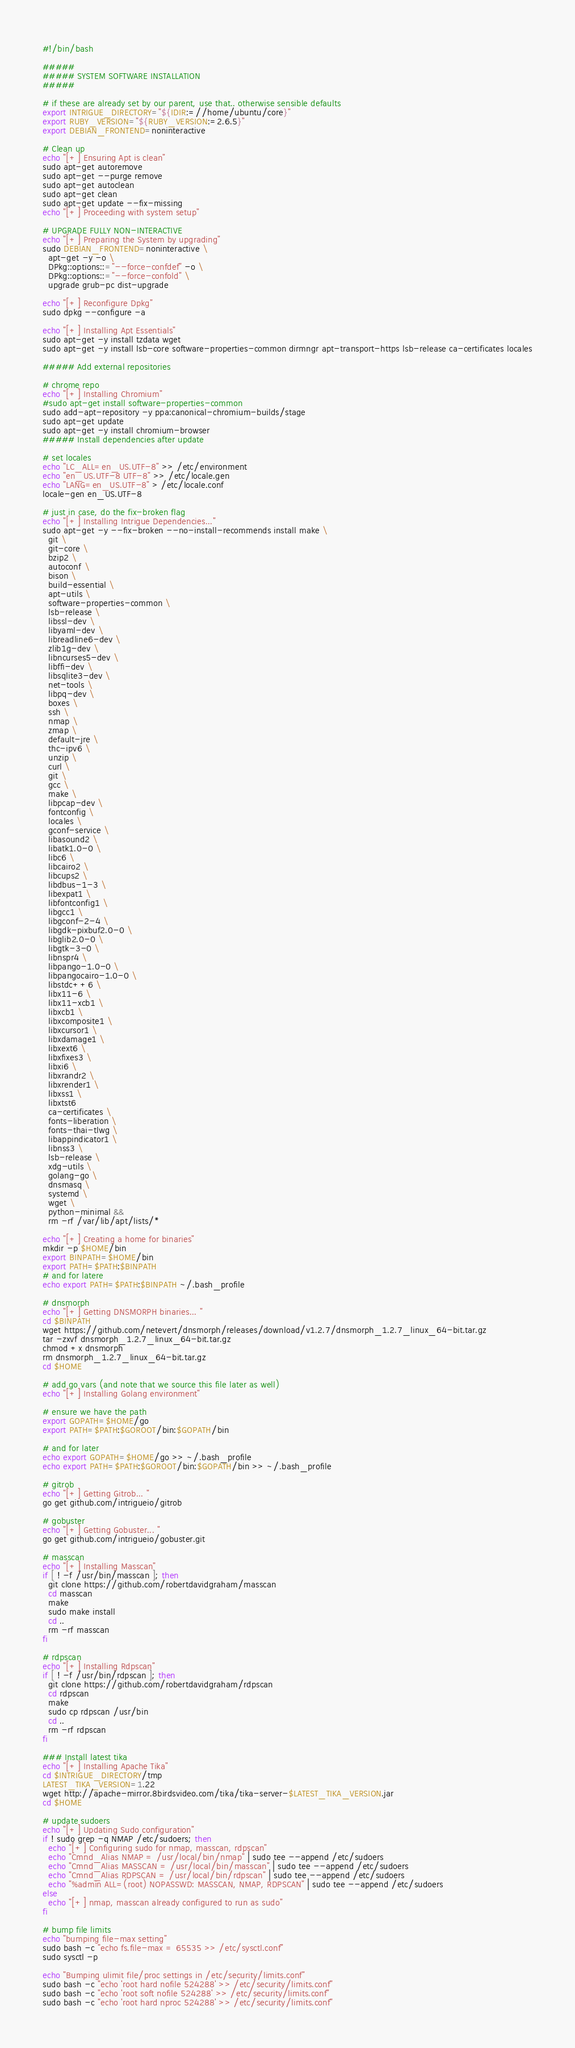<code> <loc_0><loc_0><loc_500><loc_500><_Bash_>#!/bin/bash

#####
##### SYSTEM SOFTWARE INSTALLATION
#####

# if these are already set by our parent, use that.. otherwise sensible defaults
export INTRIGUE_DIRECTORY="${IDIR:=//home/ubuntu/core}"
export RUBY_VERSION="${RUBY_VERSION:=2.6.5}"
export DEBIAN_FRONTEND=noninteractive

# Clean up
echo "[+] Ensuring Apt is clean"
sudo apt-get autoremove
sudo apt-get --purge remove
sudo apt-get autoclean
sudo apt-get clean
sudo apt-get update --fix-missing
echo "[+] Proceeding with system setup"

# UPGRADE FULLY NON-INTERACTIVE
echo "[+] Preparing the System by upgrading"
sudo DEBIAN_FRONTEND=noninteractive \
  apt-get -y -o \
  DPkg::options::="--force-confdef" -o \
  DPkg::options::="--force-confold" \
  upgrade grub-pc dist-upgrade

echo "[+] Reconfigure Dpkg"
sudo dpkg --configure -a

echo "[+] Installing Apt Essentials"
sudo apt-get -y install tzdata wget
sudo apt-get -y install lsb-core software-properties-common dirmngr apt-transport-https lsb-release ca-certificates locales

##### Add external repositories

# chrome repo
echo "[+] Installing Chromium"
#sudo apt-get install software-properties-common
sudo add-apt-repository -y ppa:canonical-chromium-builds/stage
sudo apt-get update
sudo apt-get -y install chromium-browser
##### Install dependencies after update

# set locales
echo "LC_ALL=en_US.UTF-8" >> /etc/environment
echo "en_US.UTF-8 UTF-8" >> /etc/locale.gen
echo "LANG=en_US.UTF-8" > /etc/locale.conf
locale-gen en_US.UTF-8

# just in case, do the fix-broken flag
echo "[+] Installing Intrigue Dependencies..."
sudo apt-get -y --fix-broken --no-install-recommends install make \
  git \
  git-core \
  bzip2 \
  autoconf \
  bison \
  build-essential \
  apt-utils \
  software-properties-common \
  lsb-release \
  libssl-dev \
  libyaml-dev \
  libreadline6-dev \
  zlib1g-dev \
  libncurses5-dev \
  libffi-dev \
  libsqlite3-dev \
  net-tools \
  libpq-dev \
  boxes \
  ssh \
  nmap \
  zmap \
  default-jre \
  thc-ipv6 \
  unzip \
  curl \
  git \
  gcc \
  make \
  libpcap-dev \
  fontconfig \
  locales \
  gconf-service \
  libasound2 \
  libatk1.0-0 \
  libc6 \
  libcairo2 \
  libcups2 \
  libdbus-1-3 \
  libexpat1 \
  libfontconfig1 \
  libgcc1 \
  libgconf-2-4 \
  libgdk-pixbuf2.0-0 \
  libglib2.0-0 \
  libgtk-3-0 \
  libnspr4 \
  libpango-1.0-0 \
  libpangocairo-1.0-0 \
  libstdc++6 \
  libx11-6 \
  libx11-xcb1 \
  libxcb1 \
  libxcomposite1 \
  libxcursor1 \
  libxdamage1 \
  libxext6 \
  libxfixes3 \
  libxi6 \
  libxrandr2 \
  libxrender1 \
  libxss1 \
  libxtst6 
  ca-certificates \
  fonts-liberation \
  fonts-thai-tlwg \
  libappindicator1 \
  libnss3 \
  lsb-release \
  xdg-utils \
  golang-go \
  dnsmasq \
  systemd \
  wget \
  python-minimal &&
  rm -rf /var/lib/apt/lists/*

echo "[+] Creating a home for binaries"
mkdir -p $HOME/bin
export BINPATH=$HOME/bin
export PATH=$PATH:$BINPATH
# and for latere
echo export PATH=$PATH:$BINPATH ~/.bash_profile

# dnsmorph
echo "[+] Getting DNSMORPH binaries... "
cd $BINPATH
wget https://github.com/netevert/dnsmorph/releases/download/v1.2.7/dnsmorph_1.2.7_linux_64-bit.tar.gz
tar -zxvf dnsmorph_1.2.7_linux_64-bit.tar.gz
chmod +x dnsmorph
rm dnsmorph_1.2.7_linux_64-bit.tar.gz
cd $HOME

# add go vars (and note that we source this file later as well)
echo "[+] Installing Golang environment"

# ensure we have the path
export GOPATH=$HOME/go
export PATH=$PATH:$GOROOT/bin:$GOPATH/bin

# and for later
echo export GOPATH=$HOME/go >> ~/.bash_profile
echo export PATH=$PATH:$GOROOT/bin:$GOPATH/bin >> ~/.bash_profile

# gitrob
echo "[+] Getting Gitrob... "
go get github.com/intrigueio/gitrob

# gobuster
echo "[+] Getting Gobuster... "
go get github.com/intrigueio/gobuster.git

# masscan
echo "[+] Installing Masscan"
if [ ! -f /usr/bin/masscan ]; then
  git clone https://github.com/robertdavidgraham/masscan
  cd masscan
  make
  sudo make install
  cd ..
  rm -rf masscan
fi

# rdpscan
echo "[+] Installing Rdpscan"
if [ ! -f /usr/bin/rdpscan ]; then
  git clone https://github.com/robertdavidgraham/rdpscan
  cd rdpscan
  make
  sudo cp rdpscan /usr/bin
  cd ..
  rm -rf rdpscan
fi

### Install latest tika
echo "[+] Installing Apache Tika"
cd $INTRIGUE_DIRECTORY/tmp
LATEST_TIKA_VERSION=1.22
wget http://apache-mirror.8birdsvideo.com/tika/tika-server-$LATEST_TIKA_VERSION.jar
cd $HOME

# update sudoers
echo "[+] Updating Sudo configuration"
if ! sudo grep -q NMAP /etc/sudoers; then
  echo "[+] Configuring sudo for nmap, masscan, rdpscan"
  echo "Cmnd_Alias NMAP = /usr/local/bin/nmap" | sudo tee --append /etc/sudoers
  echo "Cmnd_Alias MASSCAN = /usr/local/bin/masscan" | sudo tee --append /etc/sudoers
  echo "Cmnd_Alias RDPSCAN = /usr/local/bin/rdpscan" | sudo tee --append /etc/sudoers
  echo "%admin ALL=(root) NOPASSWD: MASSCAN, NMAP, RDPSCAN" | sudo tee --append /etc/sudoers
else
  echo "[+] nmap, masscan already configured to run as sudo"
fi

# bump file limits
echo "bumping file-max setting"
sudo bash -c "echo fs.file-max = 65535 >> /etc/sysctl.conf"
sudo sysctl -p

echo "Bumping ulimit file/proc settings in /etc/security/limits.conf"
sudo bash -c "echo 'root hard nofile 524288' >> /etc/security/limits.conf"
sudo bash -c "echo 'root soft nofile 524288' >> /etc/security/limits.conf"
sudo bash -c "echo 'root hard nproc 524288' >> /etc/security/limits.conf"</code> 